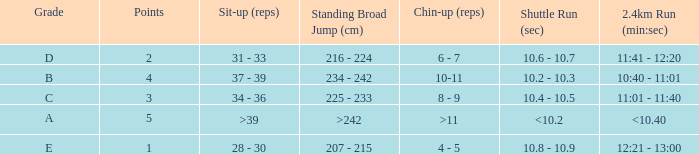Tell me the 2.4km run for points less than 2 12:21 - 13:00. 